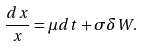<formula> <loc_0><loc_0><loc_500><loc_500>\frac { d x } { x } = \mu d t + \sigma \delta W .</formula> 